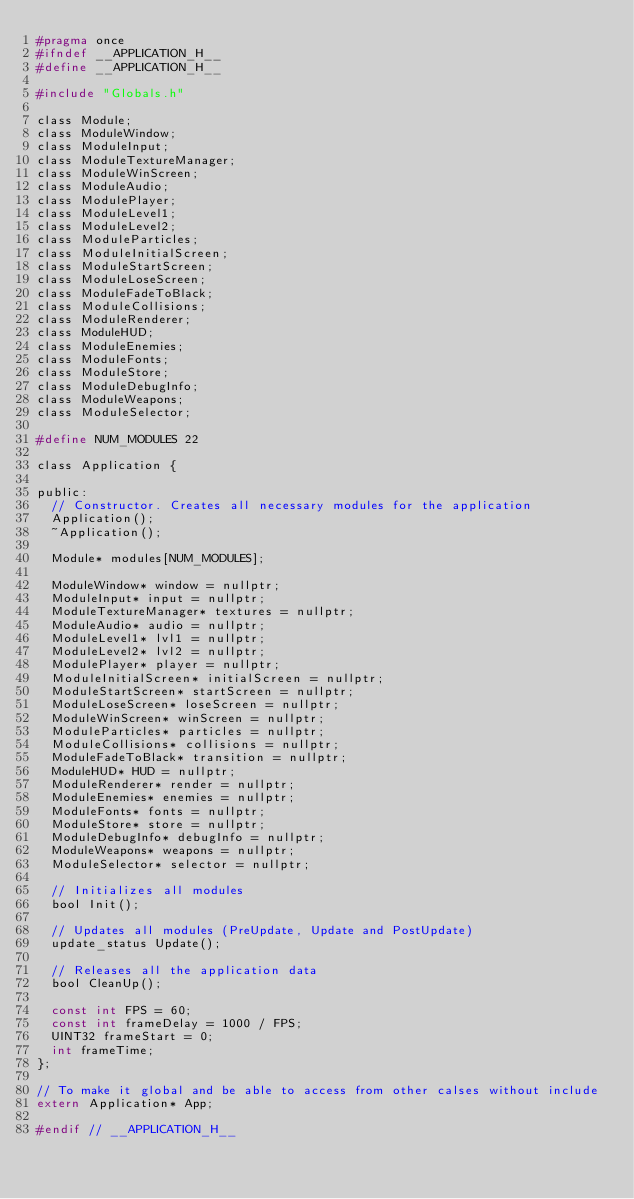<code> <loc_0><loc_0><loc_500><loc_500><_C_>#pragma once
#ifndef __APPLICATION_H__
#define __APPLICATION_H__

#include "Globals.h"

class Module;
class ModuleWindow;
class ModuleInput;
class ModuleTextureManager;
class ModuleWinScreen;
class ModuleAudio;
class ModulePlayer;
class ModuleLevel1;
class ModuleLevel2;
class ModuleParticles;
class ModuleInitialScreen;
class ModuleStartScreen;
class ModuleLoseScreen;
class ModuleFadeToBlack;
class ModuleCollisions;
class ModuleRenderer;
class ModuleHUD;
class ModuleEnemies;
class ModuleFonts;
class ModuleStore;
class ModuleDebugInfo;
class ModuleWeapons;
class ModuleSelector;

#define NUM_MODULES 22

class Application {

public:
	// Constructor. Creates all necessary modules for the application
	Application();
	~Application();

	Module* modules[NUM_MODULES];

	ModuleWindow* window = nullptr;
	ModuleInput* input = nullptr;
	ModuleTextureManager* textures = nullptr;
	ModuleAudio* audio = nullptr;
	ModuleLevel1* lvl1 = nullptr;
	ModuleLevel2* lvl2 = nullptr;
	ModulePlayer* player = nullptr;
	ModuleInitialScreen* initialScreen = nullptr;
	ModuleStartScreen* startScreen = nullptr;
	ModuleLoseScreen* loseScreen = nullptr;
	ModuleWinScreen* winScreen = nullptr;
	ModuleParticles* particles = nullptr;
	ModuleCollisions* collisions = nullptr;
	ModuleFadeToBlack* transition = nullptr;
	ModuleHUD* HUD = nullptr;
	ModuleRenderer* render = nullptr;
	ModuleEnemies* enemies = nullptr;
	ModuleFonts* fonts = nullptr;
	ModuleStore* store = nullptr;
	ModuleDebugInfo* debugInfo = nullptr;
	ModuleWeapons* weapons = nullptr;
	ModuleSelector* selector = nullptr;

	// Initializes all modules
	bool Init();

	// Updates all modules (PreUpdate, Update and PostUpdate)
	update_status Update();

	// Releases all the application data
	bool CleanUp();

	const int FPS = 60;
	const int frameDelay = 1000 / FPS;
	UINT32 frameStart = 0;
	int frameTime;
};

// To make it global and be able to access from other calses without include
extern Application* App;

#endif // __APPLICATION_H__</code> 